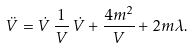<formula> <loc_0><loc_0><loc_500><loc_500>\ddot { V } = \dot { V } \, \frac { 1 } { V } \, \dot { V } + \frac { 4 m ^ { 2 } } { V } + 2 m \lambda .</formula> 